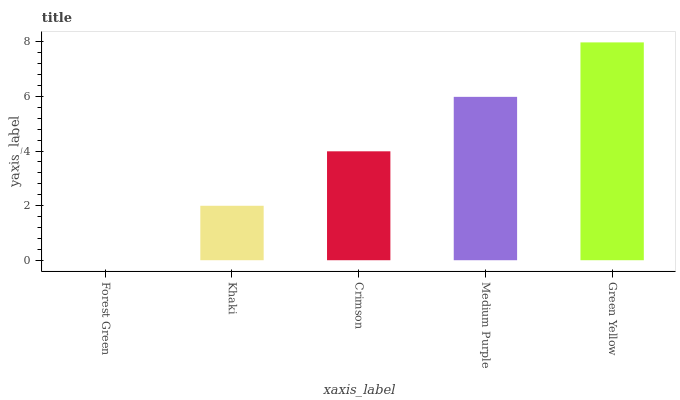Is Forest Green the minimum?
Answer yes or no. Yes. Is Green Yellow the maximum?
Answer yes or no. Yes. Is Khaki the minimum?
Answer yes or no. No. Is Khaki the maximum?
Answer yes or no. No. Is Khaki greater than Forest Green?
Answer yes or no. Yes. Is Forest Green less than Khaki?
Answer yes or no. Yes. Is Forest Green greater than Khaki?
Answer yes or no. No. Is Khaki less than Forest Green?
Answer yes or no. No. Is Crimson the high median?
Answer yes or no. Yes. Is Crimson the low median?
Answer yes or no. Yes. Is Khaki the high median?
Answer yes or no. No. Is Medium Purple the low median?
Answer yes or no. No. 